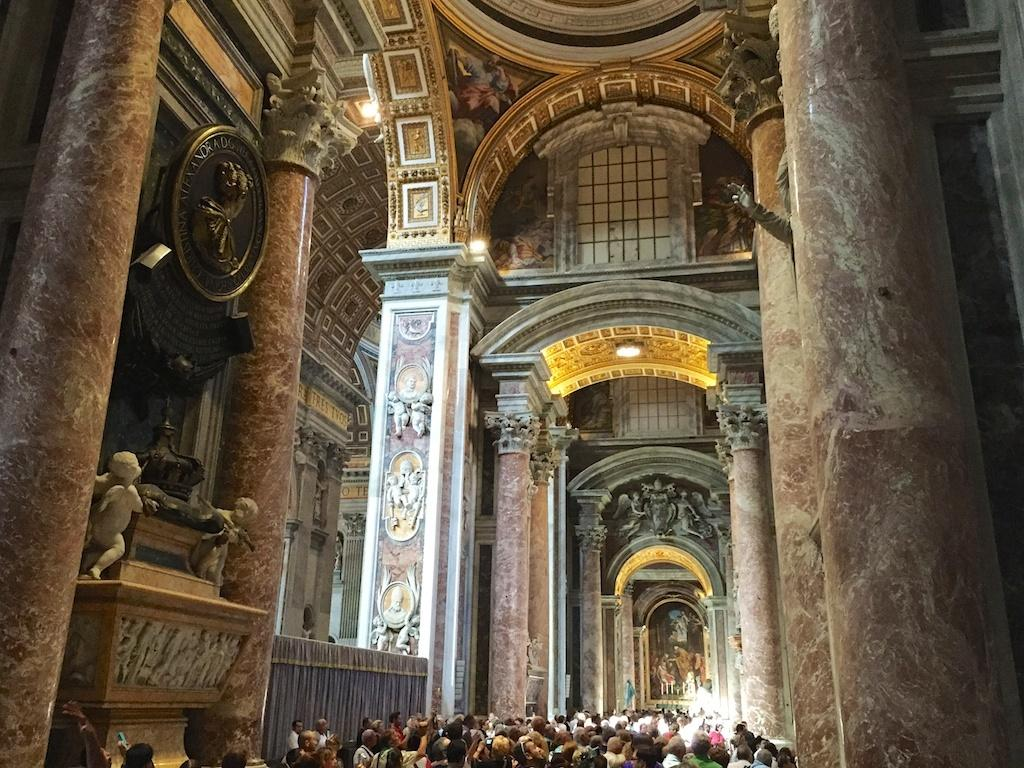What is the perspective of the image? The image is taken from inside. What can be seen on the wall in the image? There are structures on the wall in the image. What architectural elements are present in the image? There are pillars in the image. Who or what is at the bottom of the image? There are people standing at the bottom of the image. What type of cup is being used to organize the plot in the image? There is no cup or plot present in the image. 